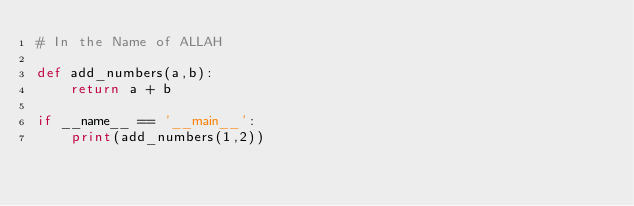Convert code to text. <code><loc_0><loc_0><loc_500><loc_500><_Python_># In the Name of ALLAH

def add_numbers(a,b):
    return a + b

if __name__ == '__main__':
    print(add_numbers(1,2))
</code> 